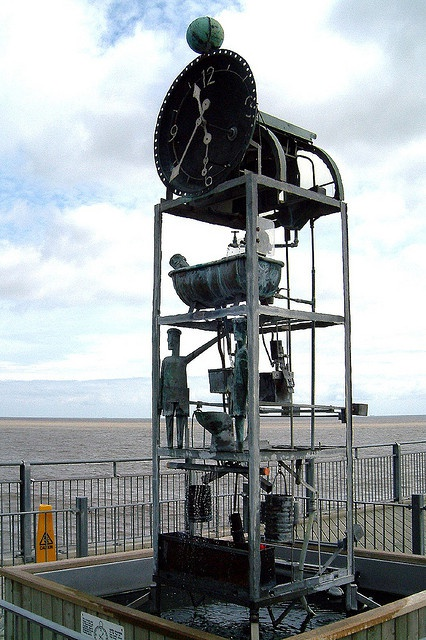Describe the objects in this image and their specific colors. I can see a clock in white, black, gray, lightgray, and darkgray tones in this image. 